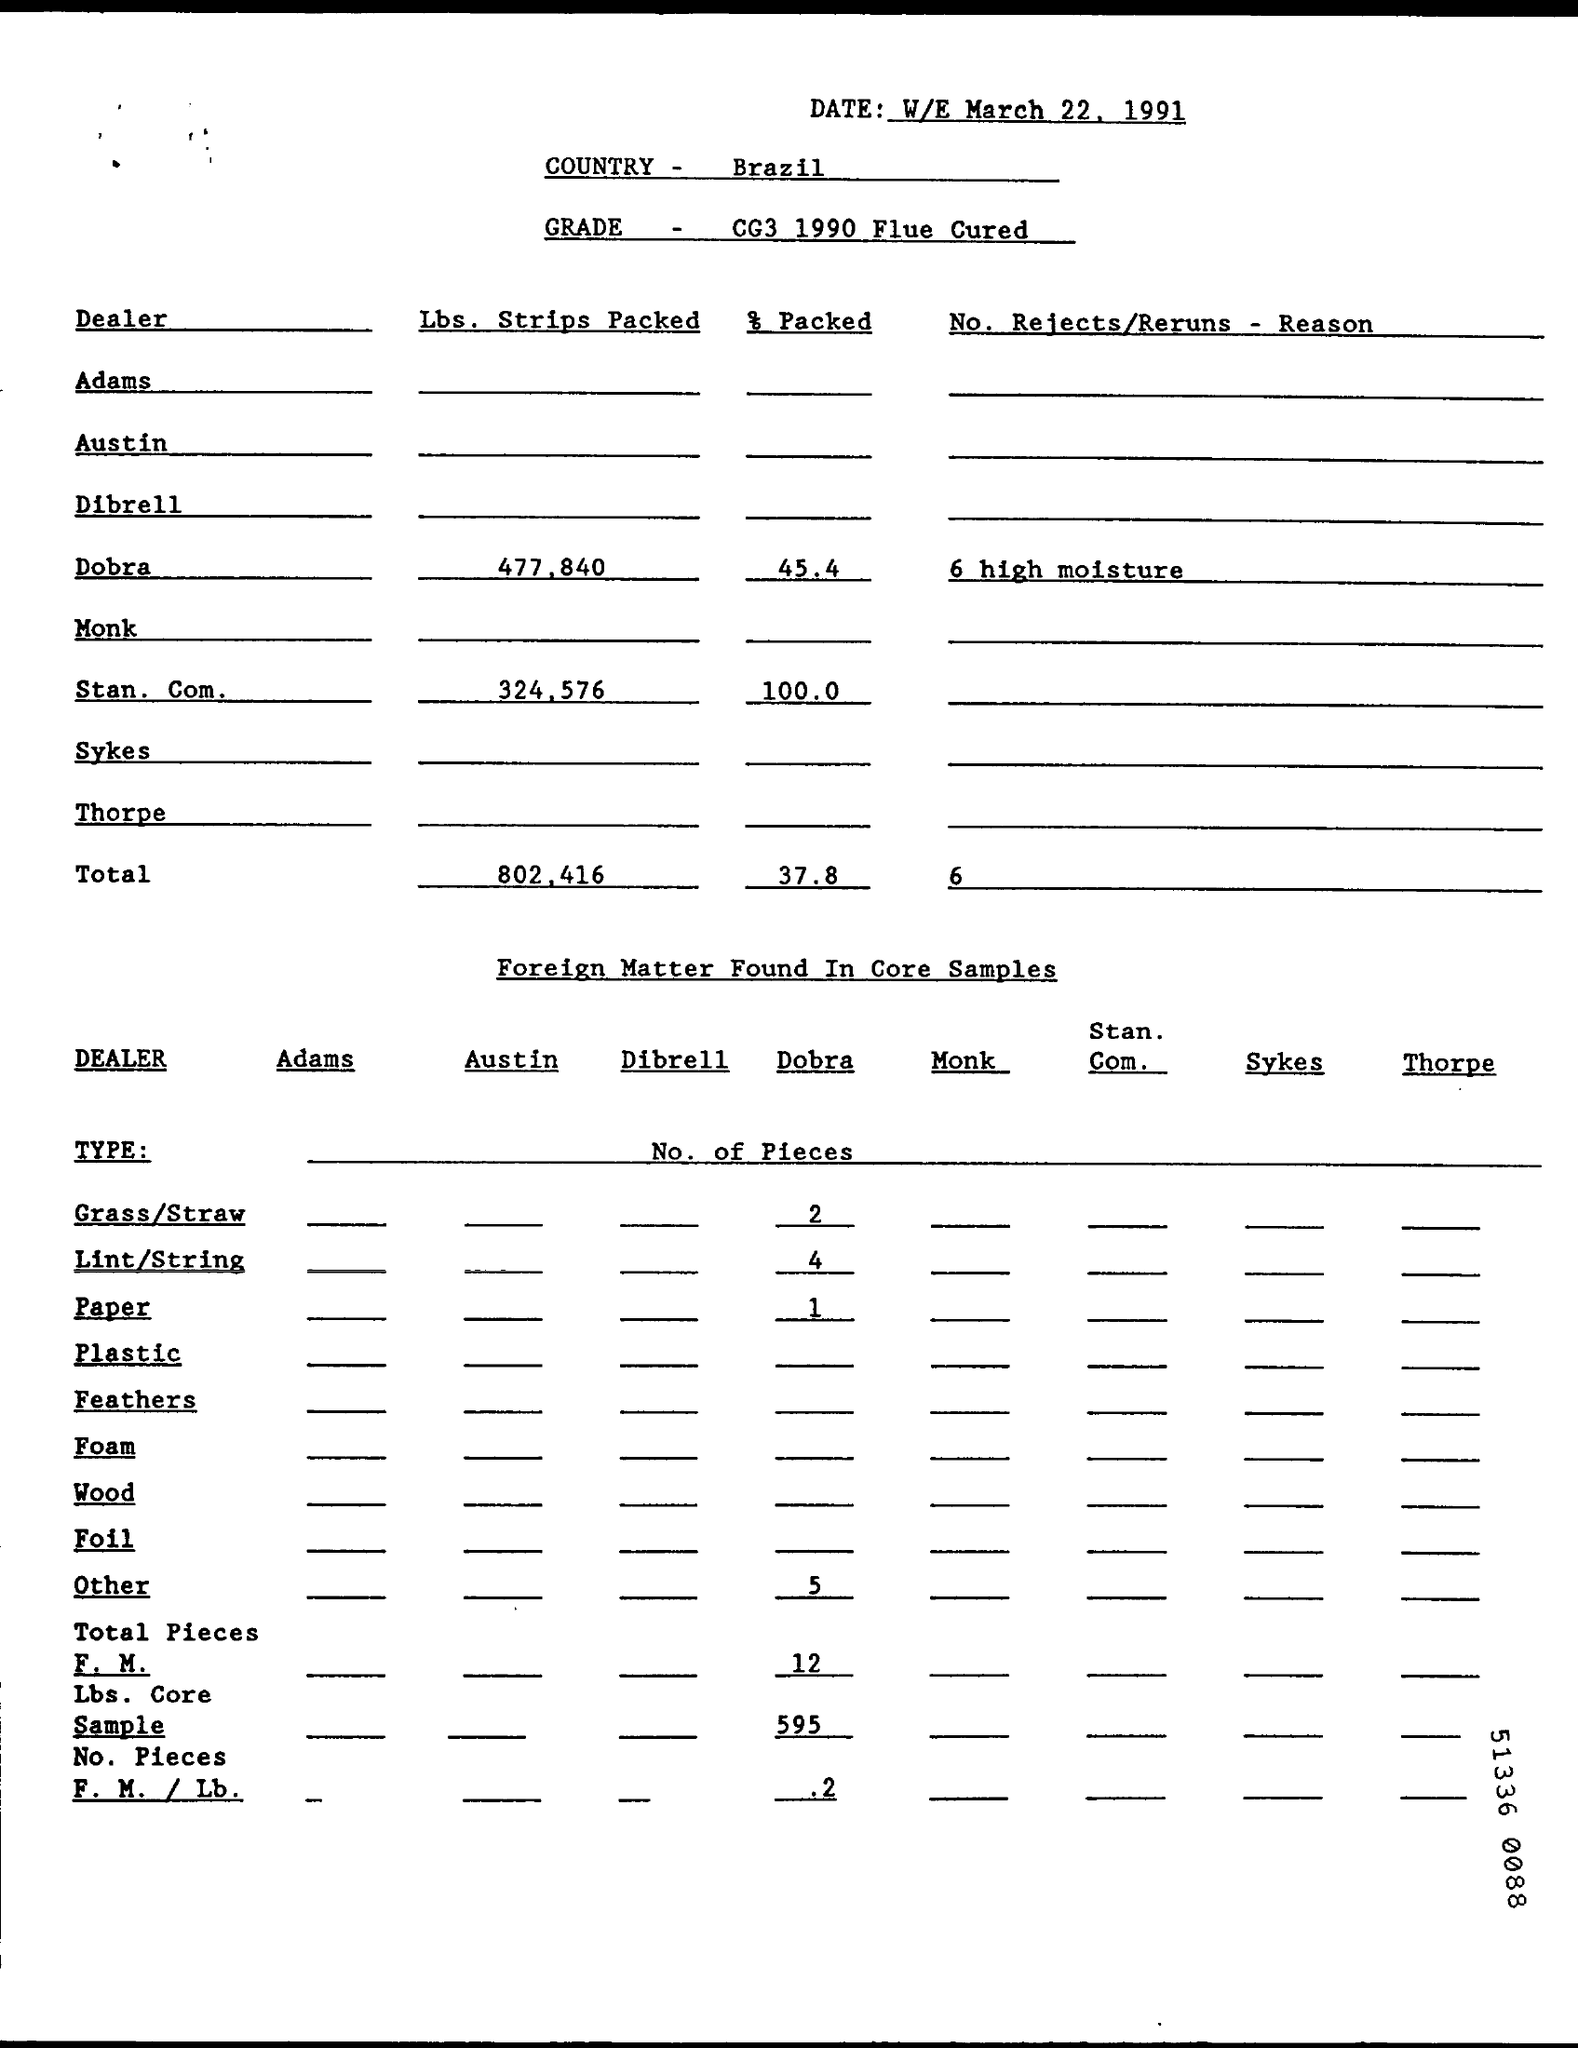Specify some key components in this picture. The grade is CG3 1990 Flue Cured, which refers to the type and year of the tobacco leaf used in the cigarette production process. The total packed percentage is 37.8... The packed percentage for Stan. Com. is 100.0... The question is asking for the weight of the Lbs. Strips Packed for Stan. Com. in kilograms (kg). The total number of pounds of strips packed is 802,416. 